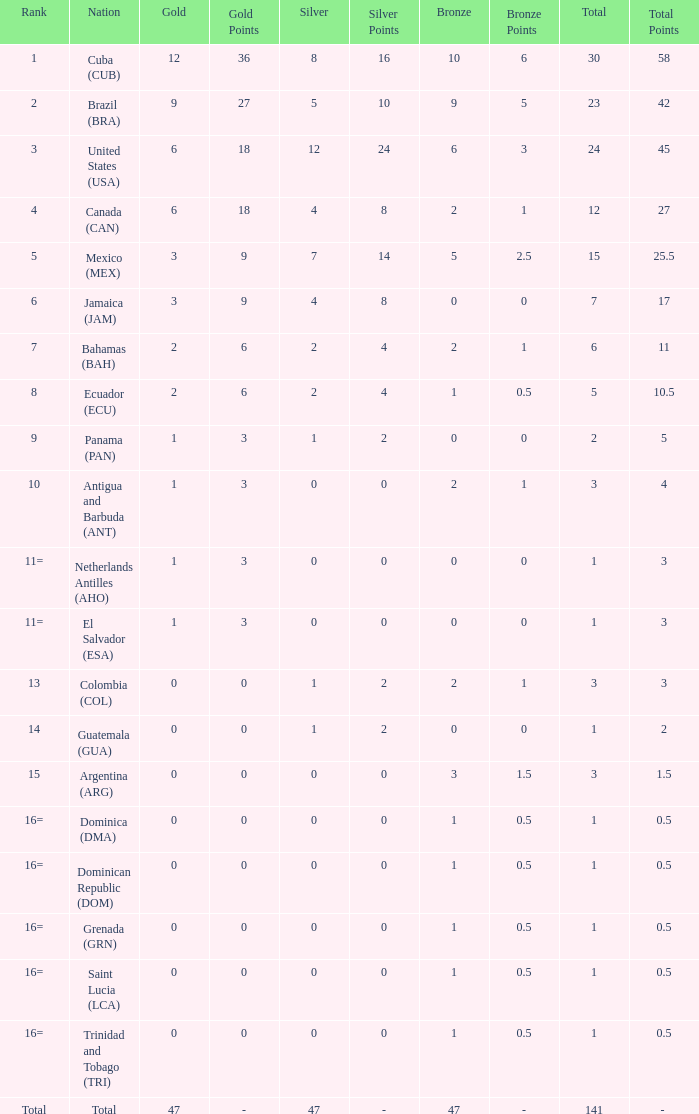What is the average silver with more than 0 gold, a Rank of 1, and a Total smaller than 30? None. 